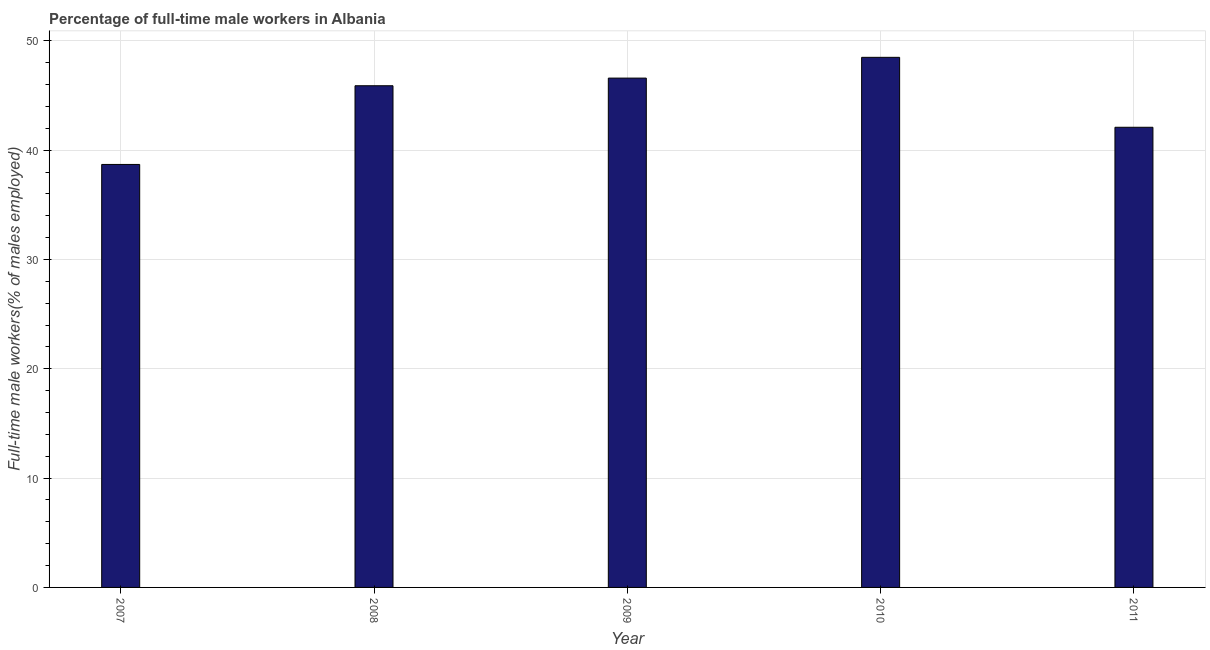Does the graph contain grids?
Your answer should be very brief. Yes. What is the title of the graph?
Give a very brief answer. Percentage of full-time male workers in Albania. What is the label or title of the X-axis?
Provide a succinct answer. Year. What is the label or title of the Y-axis?
Your answer should be compact. Full-time male workers(% of males employed). What is the percentage of full-time male workers in 2011?
Your response must be concise. 42.1. Across all years, what is the maximum percentage of full-time male workers?
Give a very brief answer. 48.5. Across all years, what is the minimum percentage of full-time male workers?
Make the answer very short. 38.7. In which year was the percentage of full-time male workers minimum?
Provide a succinct answer. 2007. What is the sum of the percentage of full-time male workers?
Give a very brief answer. 221.8. What is the difference between the percentage of full-time male workers in 2009 and 2011?
Offer a very short reply. 4.5. What is the average percentage of full-time male workers per year?
Offer a terse response. 44.36. What is the median percentage of full-time male workers?
Your response must be concise. 45.9. What is the ratio of the percentage of full-time male workers in 2007 to that in 2010?
Your answer should be compact. 0.8. Is the sum of the percentage of full-time male workers in 2008 and 2009 greater than the maximum percentage of full-time male workers across all years?
Your response must be concise. Yes. How many bars are there?
Provide a succinct answer. 5. Are all the bars in the graph horizontal?
Ensure brevity in your answer.  No. What is the difference between two consecutive major ticks on the Y-axis?
Ensure brevity in your answer.  10. What is the Full-time male workers(% of males employed) in 2007?
Your answer should be very brief. 38.7. What is the Full-time male workers(% of males employed) of 2008?
Your response must be concise. 45.9. What is the Full-time male workers(% of males employed) in 2009?
Give a very brief answer. 46.6. What is the Full-time male workers(% of males employed) in 2010?
Your response must be concise. 48.5. What is the Full-time male workers(% of males employed) of 2011?
Provide a short and direct response. 42.1. What is the difference between the Full-time male workers(% of males employed) in 2007 and 2011?
Offer a very short reply. -3.4. What is the difference between the Full-time male workers(% of males employed) in 2008 and 2009?
Offer a terse response. -0.7. What is the difference between the Full-time male workers(% of males employed) in 2008 and 2010?
Your response must be concise. -2.6. What is the difference between the Full-time male workers(% of males employed) in 2009 and 2010?
Ensure brevity in your answer.  -1.9. What is the difference between the Full-time male workers(% of males employed) in 2009 and 2011?
Provide a short and direct response. 4.5. What is the ratio of the Full-time male workers(% of males employed) in 2007 to that in 2008?
Your answer should be compact. 0.84. What is the ratio of the Full-time male workers(% of males employed) in 2007 to that in 2009?
Offer a very short reply. 0.83. What is the ratio of the Full-time male workers(% of males employed) in 2007 to that in 2010?
Offer a terse response. 0.8. What is the ratio of the Full-time male workers(% of males employed) in 2007 to that in 2011?
Offer a very short reply. 0.92. What is the ratio of the Full-time male workers(% of males employed) in 2008 to that in 2010?
Make the answer very short. 0.95. What is the ratio of the Full-time male workers(% of males employed) in 2008 to that in 2011?
Offer a terse response. 1.09. What is the ratio of the Full-time male workers(% of males employed) in 2009 to that in 2011?
Offer a very short reply. 1.11. What is the ratio of the Full-time male workers(% of males employed) in 2010 to that in 2011?
Your response must be concise. 1.15. 